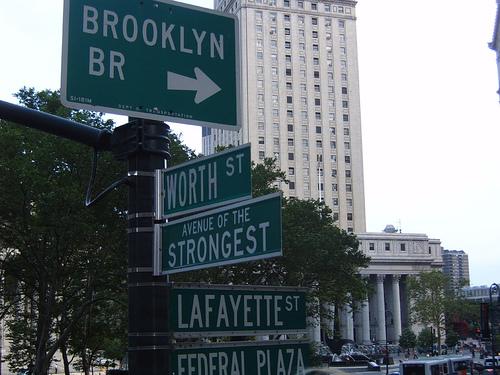What does the bottom sign say?
Keep it brief. Federal plaza. Is the Brooklyn Bridge in this city?
Give a very brief answer. Yes. What are the signs for?
Quick response, please. Streets. 